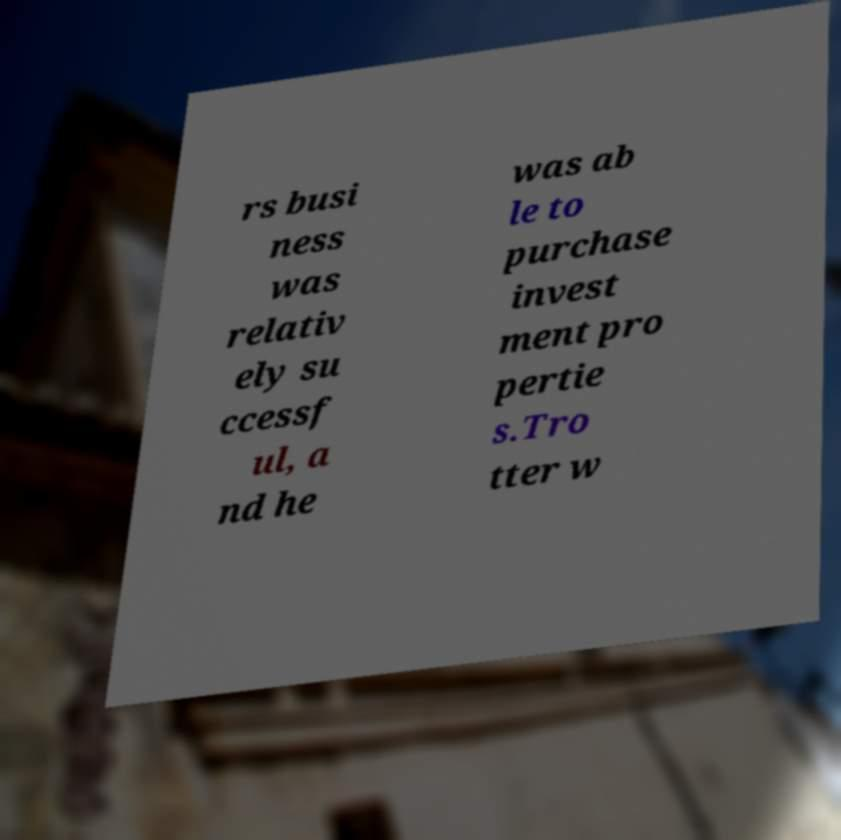Can you read and provide the text displayed in the image?This photo seems to have some interesting text. Can you extract and type it out for me? rs busi ness was relativ ely su ccessf ul, a nd he was ab le to purchase invest ment pro pertie s.Tro tter w 